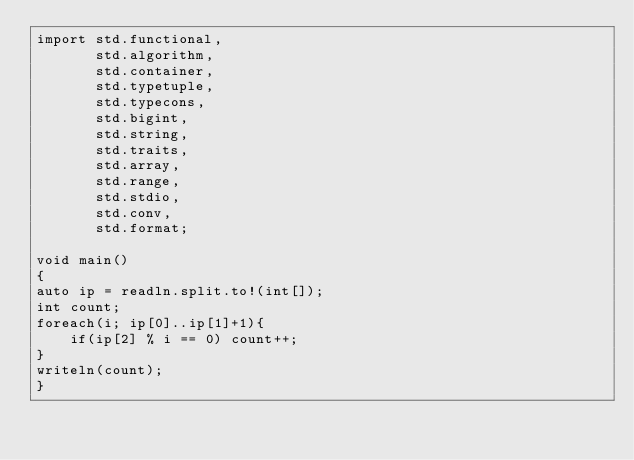Convert code to text. <code><loc_0><loc_0><loc_500><loc_500><_D_>import std.functional,
       std.algorithm,
       std.container,
       std.typetuple,
       std.typecons,
       std.bigint,
       std.string,
       std.traits,
       std.array,
       std.range,
       std.stdio,
       std.conv,
       std.format;

void main()
{
auto ip = readln.split.to!(int[]);
int count;
foreach(i; ip[0]..ip[1]+1){
	if(ip[2] % i == 0) count++;
}
writeln(count);
}
</code> 